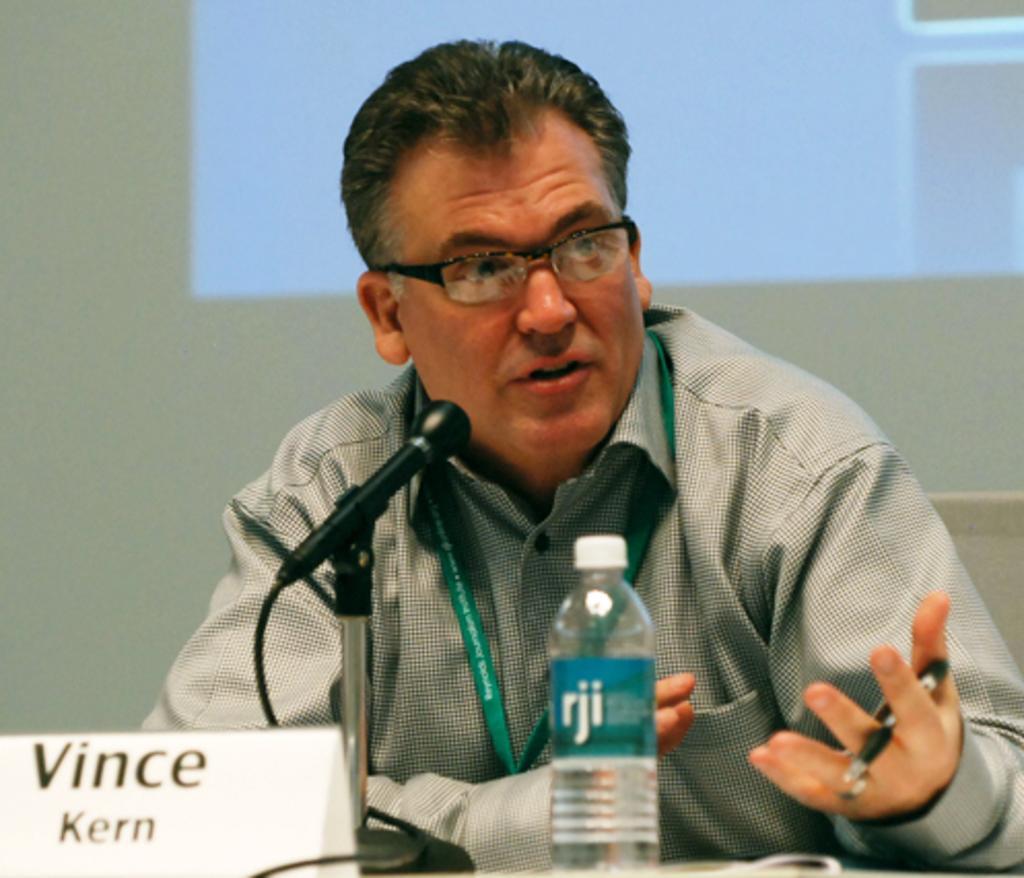In one or two sentences, can you explain what this image depicts? A man is sitting on the Table chair and speaking on the microphone. There is a bottle in front of him. 